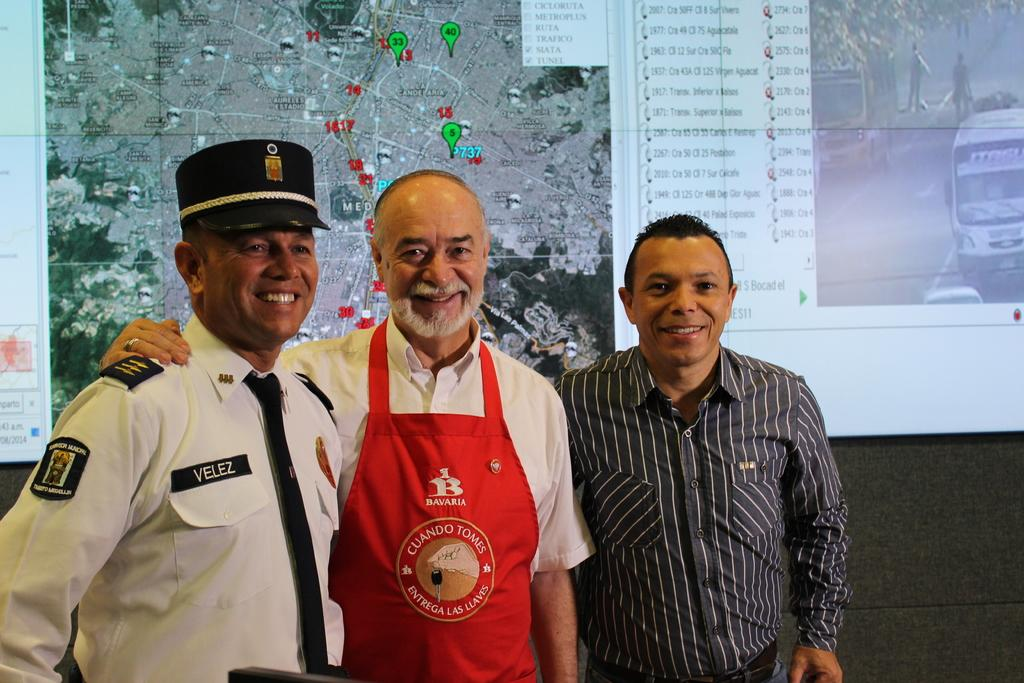<image>
Offer a succinct explanation of the picture presented. Three men one in a red apron that says Cuando Tomes on the front has his arm around the man in a white shirt and a black hat and tie. 